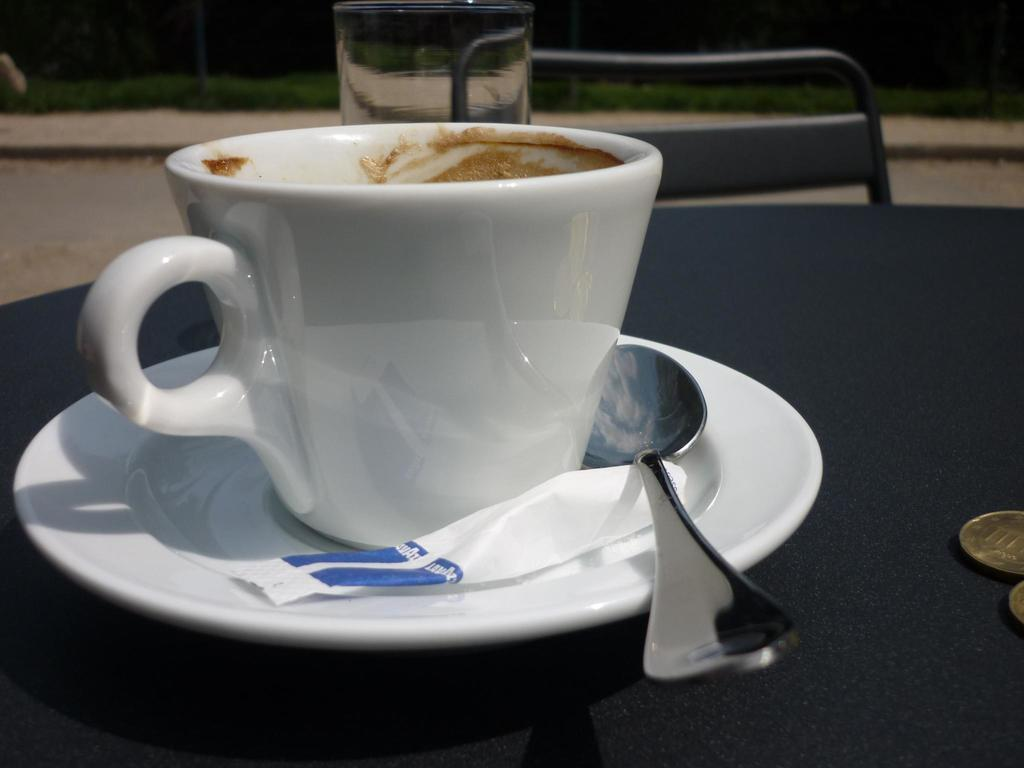What type of container is present in the image? There is a cup in the image. What accompanies the cup in the image? There is a saucer in the image. What else can be seen on the table in the image? There is a bag and a spoon on the table in the image. Where are the objects located in the image? The objects are on a table in the image. What piece of furniture is visible in the image? There is a chair in the image. What can be seen in the background of the image? There are plants in the background of the image. What type of calculator is being used by the actor in the image? There is no calculator or actor present in the image. 